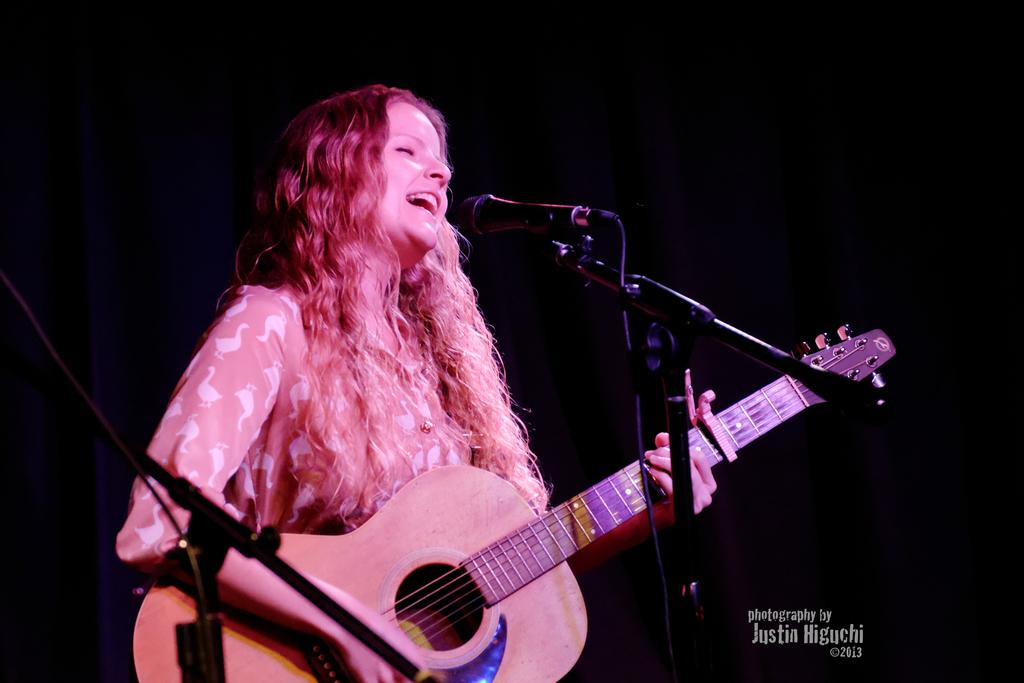Who is the main subject in the image? There is a woman in the image. What is the woman doing in the image? The woman is standing in front of a microphone and singing while playing a guitar. What can be seen in the background of the image? The background of the image is dark. What type of nest can be seen in the image? There is no nest present in the image. What is the current weather like in the image? The provided facts do not mention the weather, so it cannot be determined from the image. 